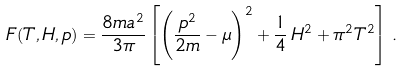<formula> <loc_0><loc_0><loc_500><loc_500>F ( T , H , p ) = \frac { 8 m a ^ { 2 } } { 3 \pi } \left [ \left ( \frac { p ^ { 2 } } { 2 m } - \mu \right ) ^ { 2 } + \frac { 1 } { 4 } \, H ^ { 2 } + \pi ^ { 2 } T ^ { 2 } \right ] \, .</formula> 